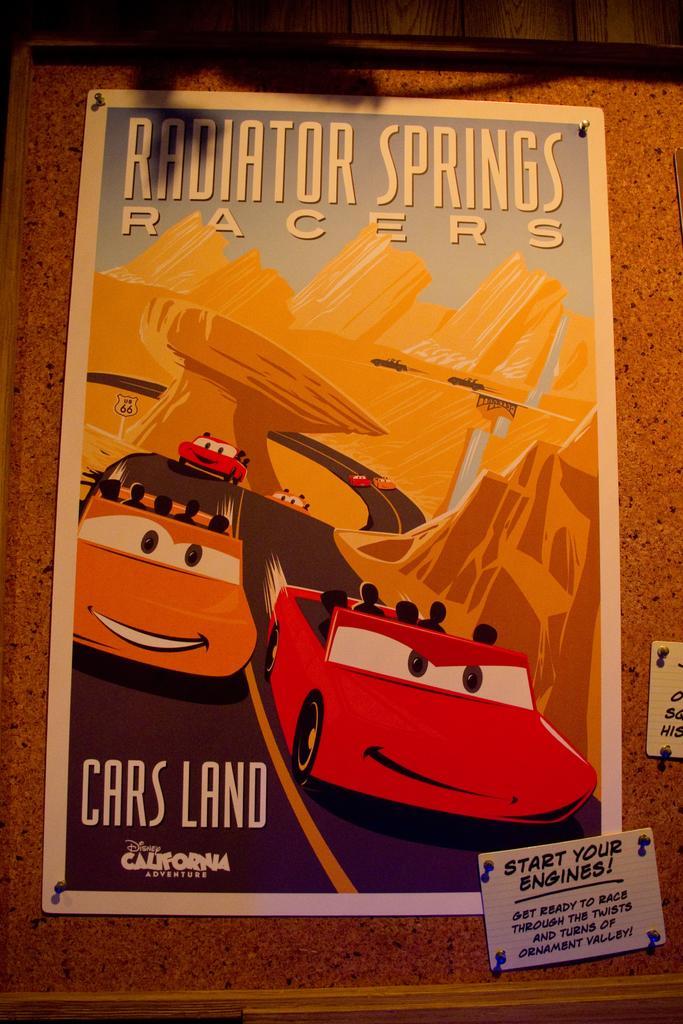Can you describe this image briefly? In this picture there is a poster which is placed on the wall. In the poster I can see the cartoon images of the cars, road and buildings. In the bottom right I can see some others stickers. 